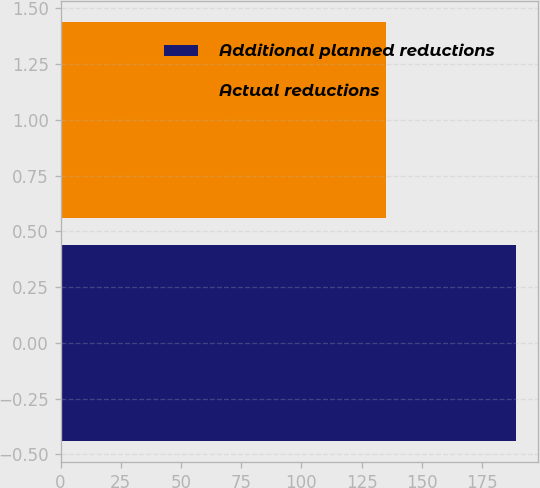Convert chart. <chart><loc_0><loc_0><loc_500><loc_500><bar_chart><fcel>Additional planned reductions<fcel>Actual reductions<nl><fcel>189<fcel>135<nl></chart> 